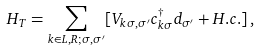Convert formula to latex. <formula><loc_0><loc_0><loc_500><loc_500>H _ { T } = \sum _ { k \in L , R ; \sigma , \sigma ^ { \prime } } [ V _ { k \sigma , \sigma ^ { \prime } } c _ { k \sigma } ^ { \dagger } d _ { \sigma ^ { \prime } } + H . c . ] \, ,</formula> 